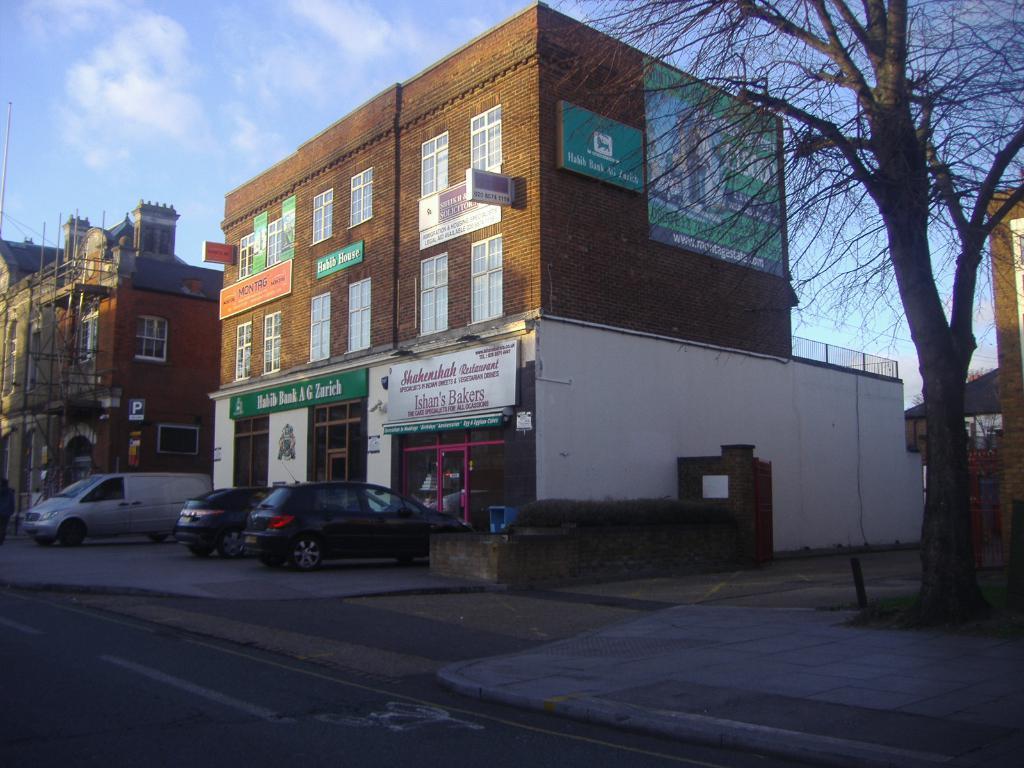Could you give a brief overview of what you see in this image? In this image I can see few vehicles, background I can see few stalls, buildings in brown and cream color, few banners attached to the wall, dried trees and the sky is in white and blue color. 